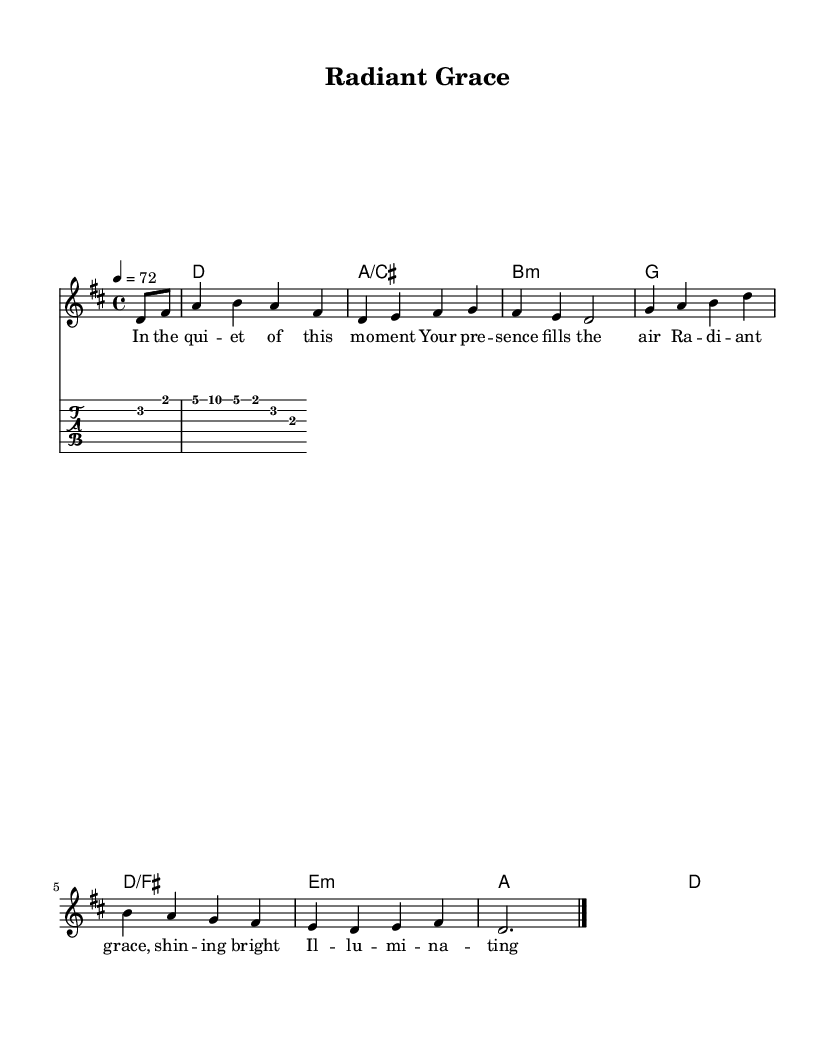What is the key signature of this music? The key signature is indicated on the staff before the notes begin. This music has two sharps, which corresponds to the key of D major.
Answer: D major What is the time signature of this music? The time signature is the fraction-like symbol at the beginning of the staff that shows how many beats are in each measure and what kind of note gets one beat. Here, it is 4/4, which means four beats per measure with the quarter note getting the beat.
Answer: 4/4 What is the tempo marking of this music? The tempo marking is provided in beats per minute, and in this case, it specifies that the music should be played at 72 beats per minute.
Answer: 72 Which chord corresponds to the first measure? The chord names written above the staff indicate which chords accompany the melody. The first measure shows a D major chord.
Answer: D How many lines are there in the lyrics? The lyrics are attached to the melody notes and are generally grouped into phrases. In this case, there are four lines of lyrics provided.
Answer: Four What type of music is this? Given the context of the lyrics and the use of religious themes in the text, the music can be classified as praise and worship music.
Answer: Praise and worship 